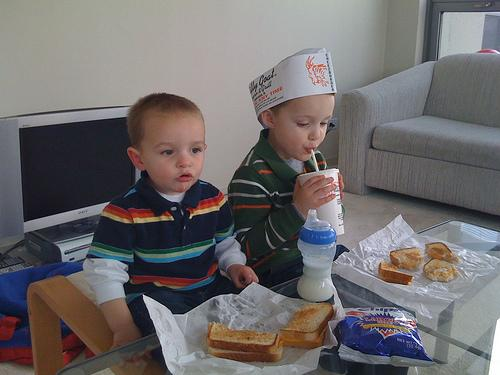What is the source of the melted product is in the center of sandwiches shown?

Choices:
A) moose
B) yak
C) dog
D) cow cow 